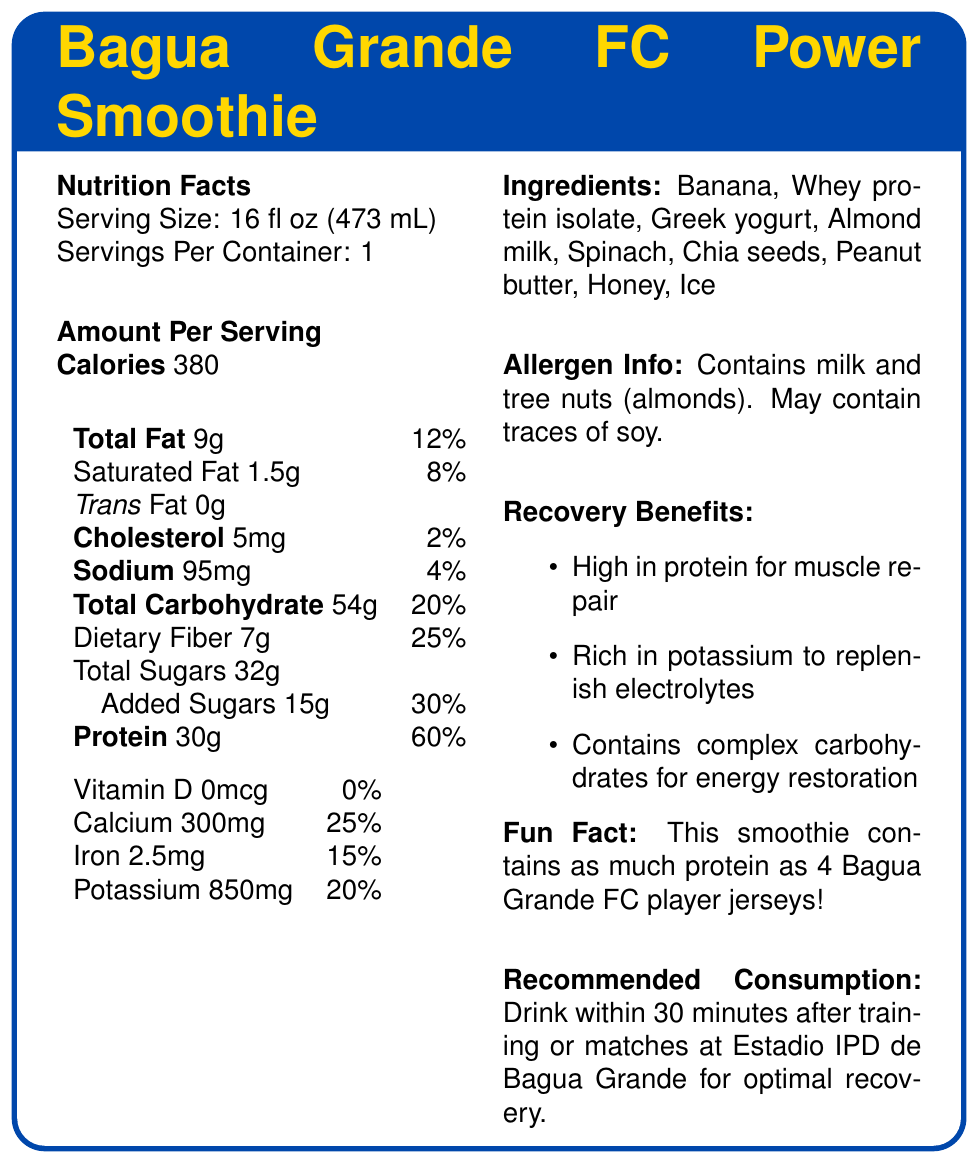what is the serving size of the Bagua Grande FC Power Smoothie? The document provides this information directly under the "Nutrition Facts" section.
Answer: 16 fl oz (473 mL) how many calories are in one serving of the smoothie? This information is found under "Amount Per Serving" in the "Calories" section.
Answer: 380 what percentage of the daily value for protein does the smoothie provide? This is explicitly listed next to the protein amount (30g).
Answer: 60% how much dietary fiber does the smoothie contain? This value is listed under "Total Carbohydrate" in the dietary fiber section.
Answer: 7g what are the three main recovery benefits of the smoothie? This information is stated in the "Recovery Benefits" section.
Answer: High in protein for muscle repair, Rich in potassium to replenish electrolytes, Contains complex carbohydrates for energy restoration which ingredient in the smoothie might be a concern for someone allergic to tree nuts? A. Honey B. Almond milk C. Chia seeds D. Spinach The allergen information lists tree nuts (almonds), and almond milk is specifically mentioned as an ingredient.
Answer: B. Almond milk what is the amount of added sugars in the smoothie? A. 10g B. 15g C. 20g D. 25g The added sugars are listed explicitly with a daily value percentage of 30%.
Answer: B. 15g is the smoothie free from trans fat? The label lists "Trans Fat 0g", indicating it is free from trans fat.
Answer: Yes describe the main purpose of the Bagua Grande FC Power Smoothie document. The document contains various sections explaining the smoothie’s content and benefits, presenting a clear picture of its role in supporting athletic recovery.
Answer: The document is a Nutrition Facts Label for the "Bagua Grande FC Power Smoothie," designed for football players' post-training recovery. It provides detailed nutritional information, ingredients, allergen info, recovery benefits, a fun fact, and recommended consumption instructions. how does the amount of calcium in the smoothie compare to the daily value percentage? The smoothie contains 300mg of calcium, which fulfills 25% of the daily value.
Answer: 25% how much saturated fat does one serving of the smoothie contain? This value is listed directly under the "Total Fat" section.
Answer: 1.5g what is the recommended time to consume the smoothie for optimal recovery? This is mentioned in the "Recommended Consumption" section.
Answer: Within 30 minutes after training or matches at Estadio IPD de Bagua Grande how many jerseys' worth of protein is in the smoothie according to the fun fact? The "Fun Fact" section provides this unique comparison.
Answer: As much protein as 4 Bagua Grande FC player jerseys can you determine the exact protein source used in the smoothie from the document? The document lists "Whey protein isolate" as one of the ingredients.
Answer: Yes how much potassium does the smoothie contain and what percentage of the daily value does this represent? This information is stated in the "Nutrition Facts" section under "Potassium."
Answer: 850mg, 20% is there any vitamin D in the smoothie? The document specifies "Vitamin D 0mcg" and "0%" daily value, indicating the absence of vitamin D.
Answer: No what are the main ingredients of the Bagua Grande FC Power Smoothie? This list is provided in the "Ingredients" section.
Answer: Banana, Whey protein isolate, Greek yogurt, Almond milk, Spinach, Chia seeds, Peanut butter, Honey, Ice how much sodium is found in one serving of the smoothie? This is listed in the "Sodium" section under "Amount Per Serving."
Answer: 95mg how many servings are in one container of the smoothie? This information is listed at the beginning of the "Nutrition Facts" section.
Answer: 1 how much iron does the smoothie contain and what percentage of the daily value does it represent? This is listed under the "Iron" section in the "Nutrition Facts" portion.
Answer: 2.5mg, 15% what is the overall fat content in the smoothie? A. 5g B. 6g C. 7g D. 9g The total fat is listed under "Total Fat" with an amount of 9g.
Answer: D. 9g is the amount of dietary fiber in the smoothie higher than the amount of added sugars? The smoothie contains 7g of dietary fiber and 15g of added sugars, making the added sugars amount higher.
Answer: No 